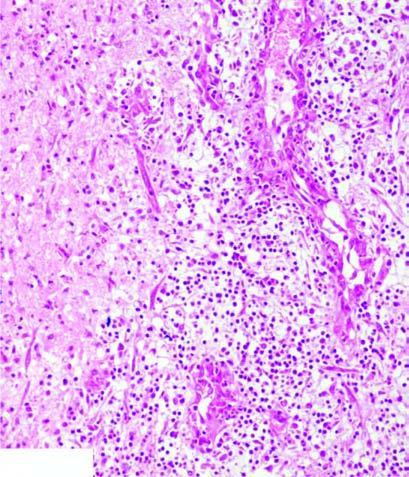what does the surrounding zone show?
Answer the question using a single word or phrase. Granulation tissue and gliosis 